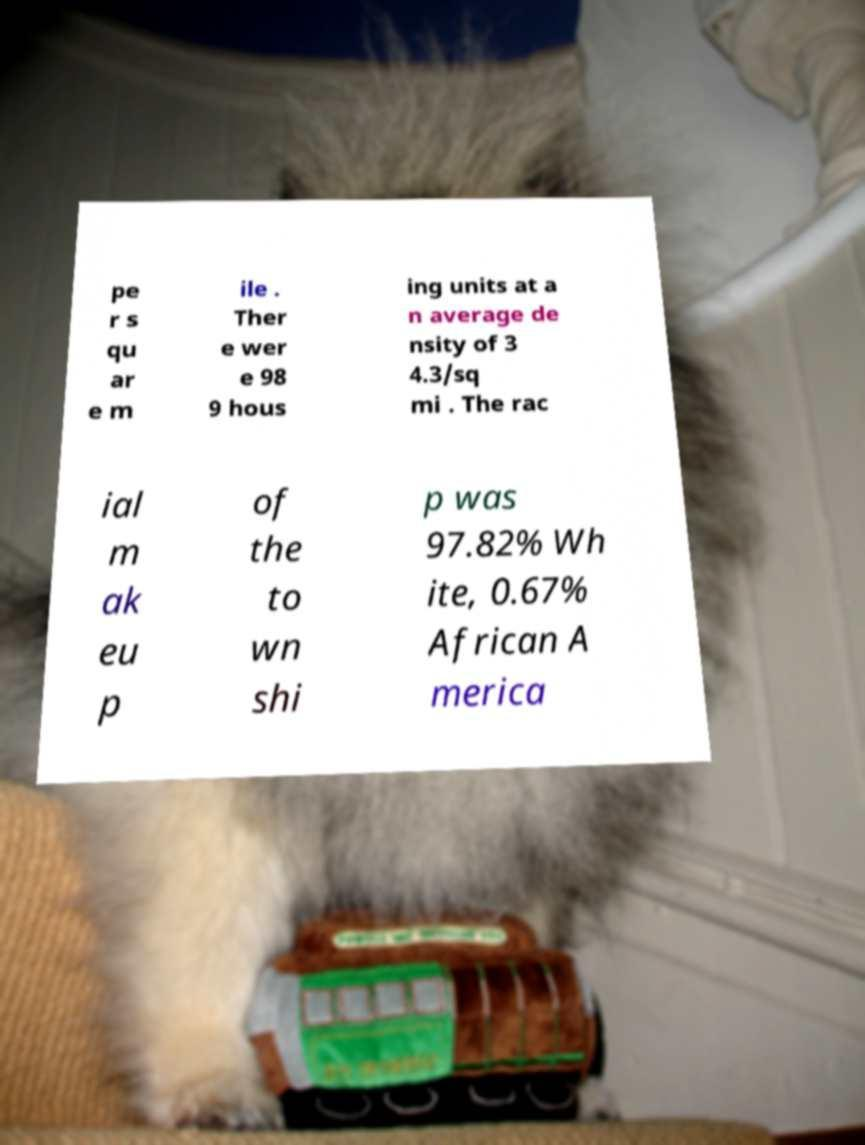I need the written content from this picture converted into text. Can you do that? pe r s qu ar e m ile . Ther e wer e 98 9 hous ing units at a n average de nsity of 3 4.3/sq mi . The rac ial m ak eu p of the to wn shi p was 97.82% Wh ite, 0.67% African A merica 